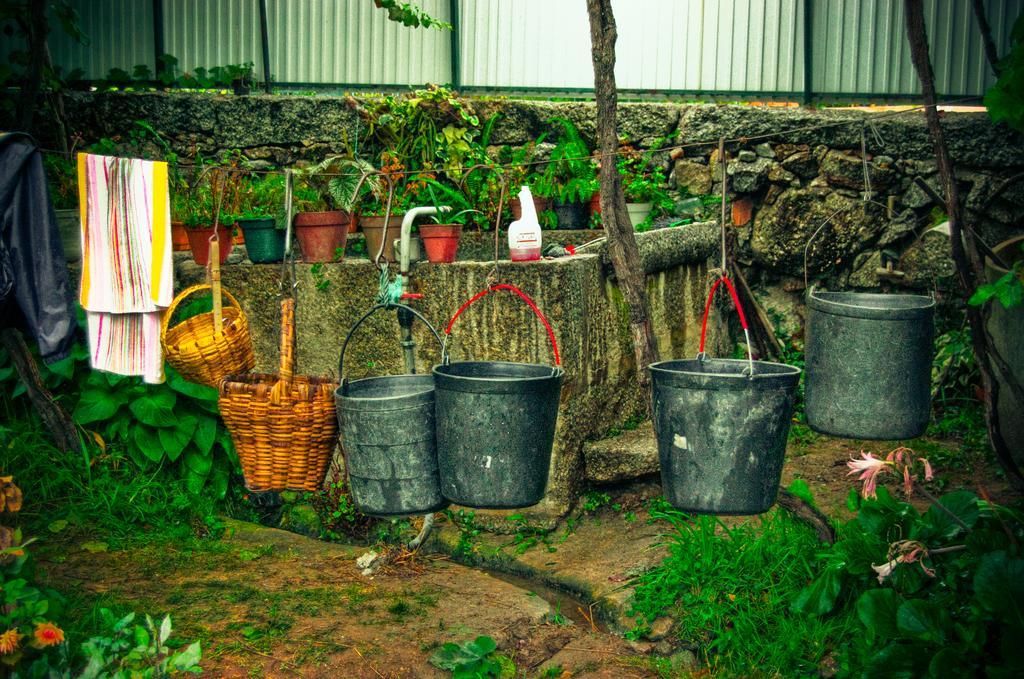Describe this image in one or two sentences. Here on a rope there are clothes,2 baskets and 4 buckets are hanging on it. In the background there are house plants,a bottle,plants,flowers,trees,wall and a fence. 